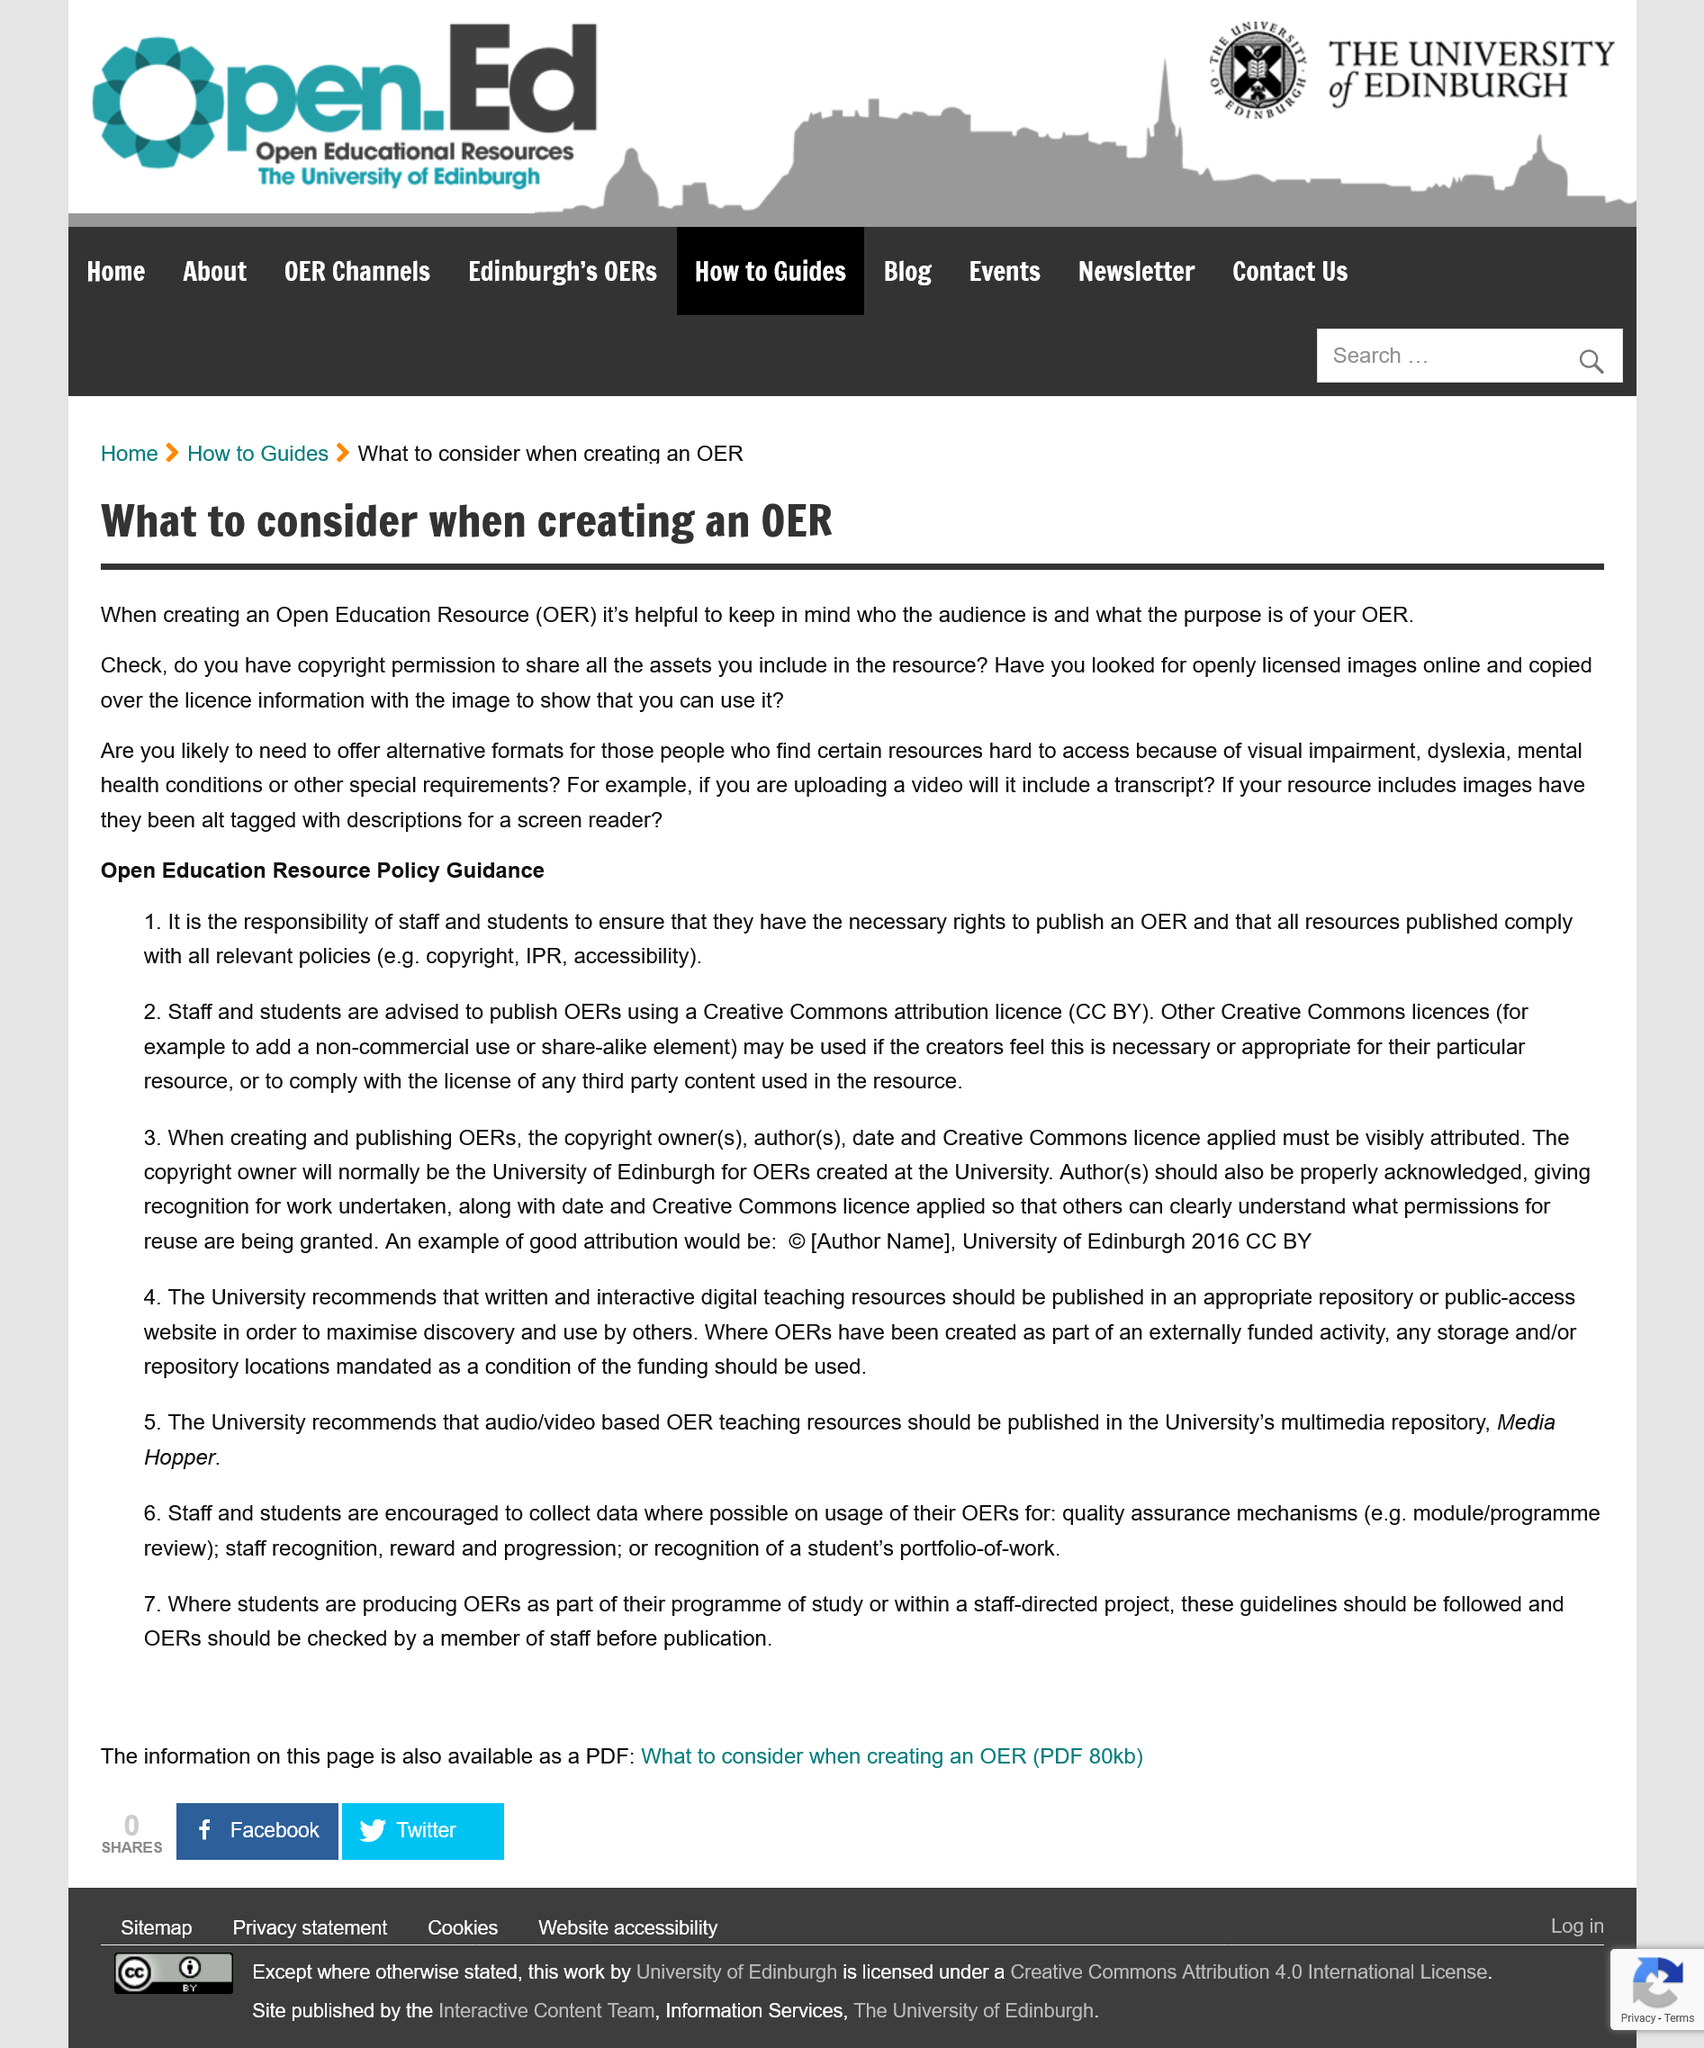Identify some key points in this picture. There are two procedures listed in the Open Education Resource Policy Guidance section. Open Education Resources" refers to educational materials that are made freely available for anyone to use, modify, and distribute. When creating and publishing OERs, it is necessary to attribute the copyright owner(s), author(s), date, and the Creative Commons license applied in a visible manner. The title of this section is 'What to consider when creating an OER' and it covers important factors to keep in mind when creating open educational resources. The University recommends that written and interactive digital teaching resources be published in an appropriate repository or public access website. 